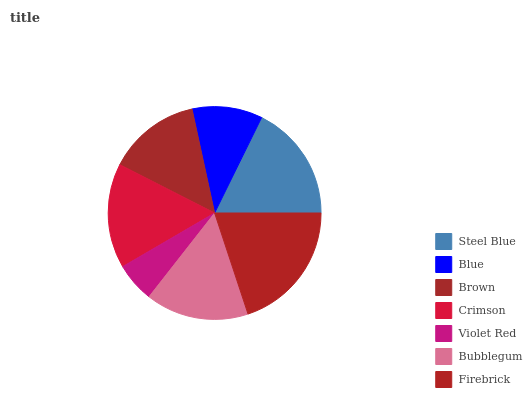Is Violet Red the minimum?
Answer yes or no. Yes. Is Firebrick the maximum?
Answer yes or no. Yes. Is Blue the minimum?
Answer yes or no. No. Is Blue the maximum?
Answer yes or no. No. Is Steel Blue greater than Blue?
Answer yes or no. Yes. Is Blue less than Steel Blue?
Answer yes or no. Yes. Is Blue greater than Steel Blue?
Answer yes or no. No. Is Steel Blue less than Blue?
Answer yes or no. No. Is Bubblegum the high median?
Answer yes or no. Yes. Is Bubblegum the low median?
Answer yes or no. Yes. Is Steel Blue the high median?
Answer yes or no. No. Is Blue the low median?
Answer yes or no. No. 